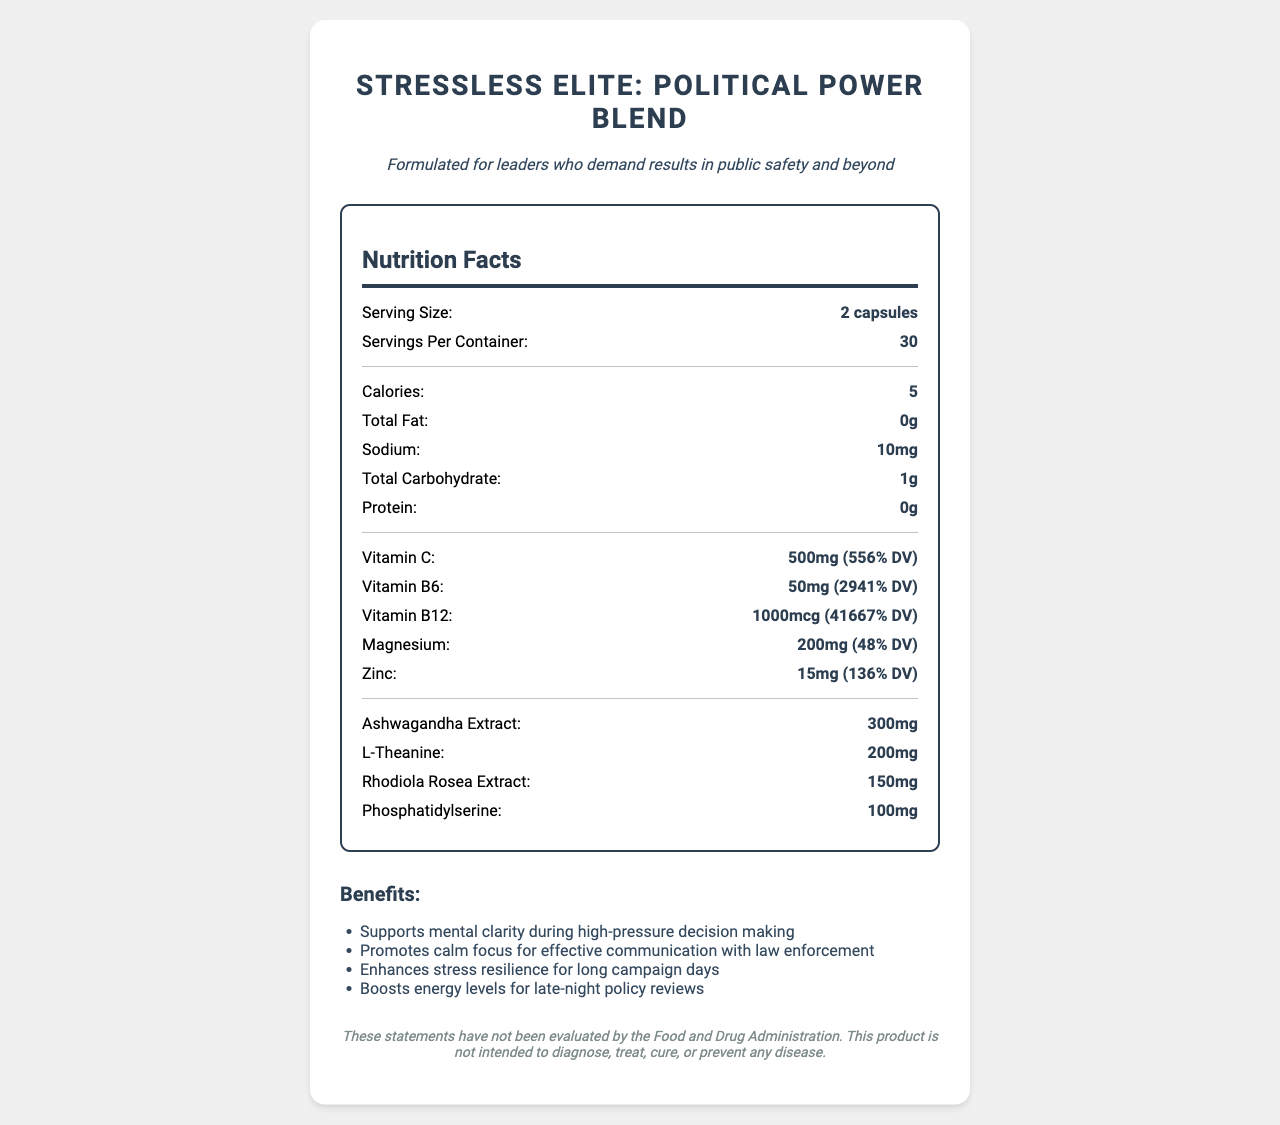what is the serving size? The serving size is mentioned at the top of the nutrition facts section as "Serving Size: 2 capsules".
Answer: 2 capsules how much Vitamin C is in one serving? The nutrition facts section lists "Vitamin C: 500mg (556% DV)" per serving.
Answer: 500mg how many calories are in a serving? The nutrition facts section lists "Calories: 5".
Answer: 5 which ingredient is present in the highest quantity for stress management? A. Ashwagandha Extract B. L-Theanine C. Rhodiola Rosea Extract The nutrition facts show that Ashwagandha Extract is listed as 300mg, higher than the others.
Answer: Ashwagandha Extract what is the daily value percentage of Vitamin B12? The nutrition facts section lists "Vitamin B12: 1000mcg (41667% DV)".
Answer: 41667% does the product contain any fat? The nutrition facts section lists "Total Fat: 0g", indicating that there is no fat in the product.
Answer: No is this product suitable for someone with soy allergies? The allergen info states that it is "Manufactured in a facility that also processes soy", which might not be suitable for someone with soy allergies.
Answer: No what are the benefits of this supplement for someone in a high-pressure political role? The benefits section lists these specific benefits aimed at individuals in high-pressure roles.
Answer: Supports mental clarity during high-pressure decision making, Promotes calm focus for effective communication with law enforcement, Enhances stress resilience for long campaign days, Boosts energy levels for late-night policy reviews how should the product be stored? The storage instructions are "Store in a cool, dry place away from direct sunlight".
Answer: In a cool, dry place away from direct sunlight what should one do before starting to use this supplement if they have a medical condition? The warning section advises to "Consult your healthcare provider before use if you have a medical condition".
Answer: Consult a healthcare provider how many servings are in the container? The nutrition facts section lists "Servings Per Container: 30".
Answer: 30 what is the purpose of phosphatidylserine in the supplement? A. Boosts immune function B. Supports cognitive function C. Acts as a filler ingredient Phosphatidylserine is generally known for supporting cognitive function, particularly in high-stress environments.
Answer: Supports cognitive function who manufactures this supplement? A. Vitamix B. PolitiVite Nutrition C. NutriCare The manufacturer's information states "PolitiVite Nutrition, Washington D.C.".
Answer: PolitiVite Nutrition are the health benefits of this supplement evaluated by the FDA? The disclaimer states "These statements have not been evaluated by the Food and Drug Administration."
Answer: No summarize the main information presented in the document. The document includes detailed nutrition facts, benefits, usage instructions, warnings, and additional information specific to this vitamin supplement targeted for political leaders.
Answer: The document presents the nutrition facts for "StressLess Elite: Political Power Blend," describing its serving size, vitamin content, additional ingredients, allergen info, directions, warnings, storage instructions, manufacturer, and disclaimer. The supplement is designed to support mental clarity, calm focus, stress resilience, and energy levels for individuals in high-pressure political roles. what is the magnesium content per serving, and why could it be important? The nutrition facts section lists "Magnesium: 200mg (48% DV)." Magnesium is important as it helps in stress management by supporting relaxation and muscle function.
Answer: 200mg (48% DV) what effect does the supplement claim to have on energy levels? The benefits section mentions "Boosts energy levels for late-night policy reviews".
Answer: Boosts energy levels for late-night policy reviews which ingredient does NOT seem to contribute to stress management directly? Microcrystalline cellulose is listed under "other ingredients" and is typically used as a filler and doesn't have a direct impact on stress management.
Answer: Microcrystalline cellulose what additional steps should vegetarian users follow when considering this supplement? The supplement lists "Vegetable capsule" but vegetarian users may need to confirm its source and compatibility with their dietary restrictions.
Answer: Review the ingredient "Vegetable capsule" to ensure it meets their dietary requirements can we determine how the product supports communication with law enforcement? The document states it "Promotes calm focus for effective communication with law enforcement" but does not provide specific details on how this is achieved beyond listing the ingredients.
Answer: Cannot be determined 